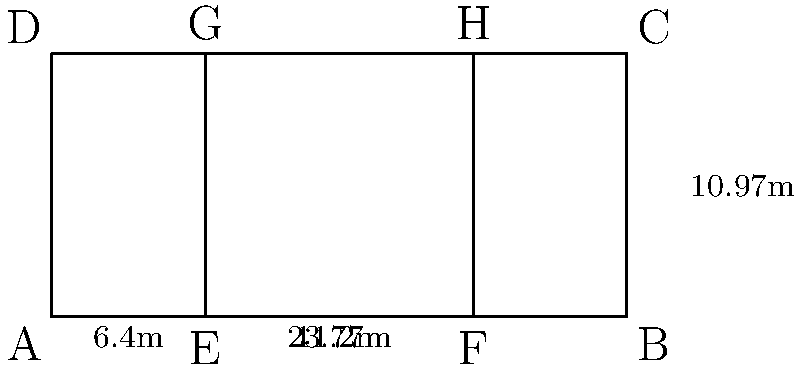You're evaluating a potential training facility with a standard tennis court. The court's dimensions are shown in the diagram above. If you need to resurface the entire court, including the areas outside the singles lines but within the doubles lines, what area (in square meters) would need to be resurfaced? Let's approach this step-by-step:

1) First, we need to calculate the total area of the court:
   Total area = Length × Width
   $$ 23.77 \text{ m} \times 10.97 \text{ m} = 260.7569 \text{ m}^2 $$

2) Now, we need to calculate the area of the singles court:
   Singles court width = Total width - (2 × width of each side)
   $$ 10.97 \text{ m} - (2 \times 1.37 \text{ m}) = 8.23 \text{ m} $$
   Singles court length = $23.77 \text{ m}$ (same as total length)
   
   Singles court area = $23.77 \text{ m} \times 8.23 \text{ m} = 195.6271 \text{ m}^2$

3) The area to be resurfaced is the difference between the total area and the singles court area:
   $$ 260.7569 \text{ m}^2 - 195.6271 \text{ m}^2 = 65.1298 \text{ m}^2 $$

4) Rounding to two decimal places:
   $$ 65.13 \text{ m}^2 $$
Answer: 65.13 m² 